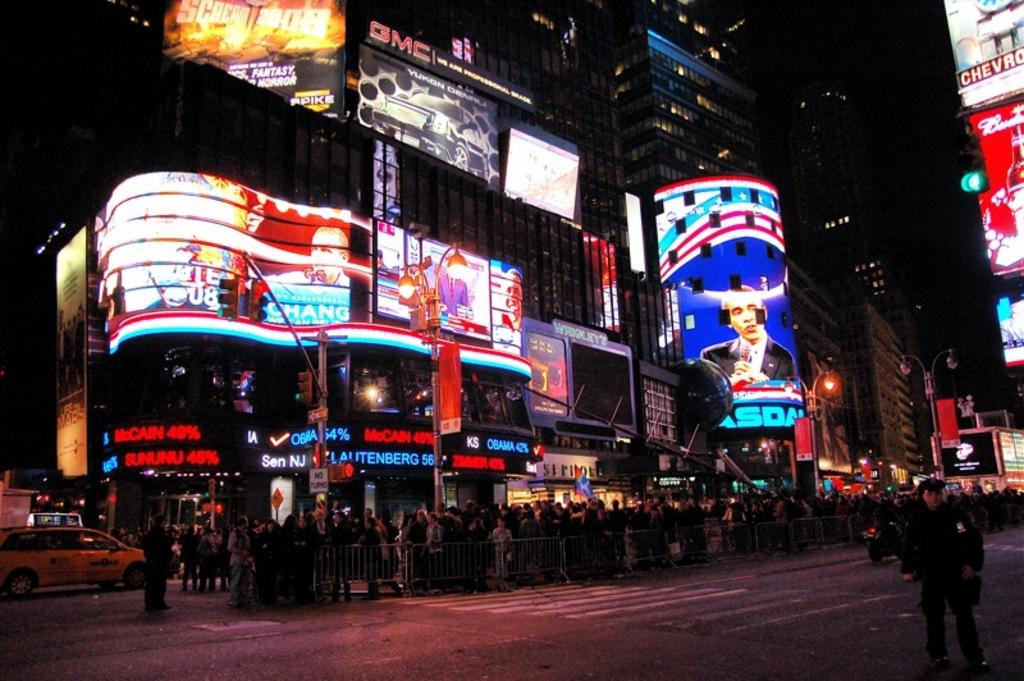Provide a one-sentence caption for the provided image. A busy city street at night with a chevrolet sign among others. 